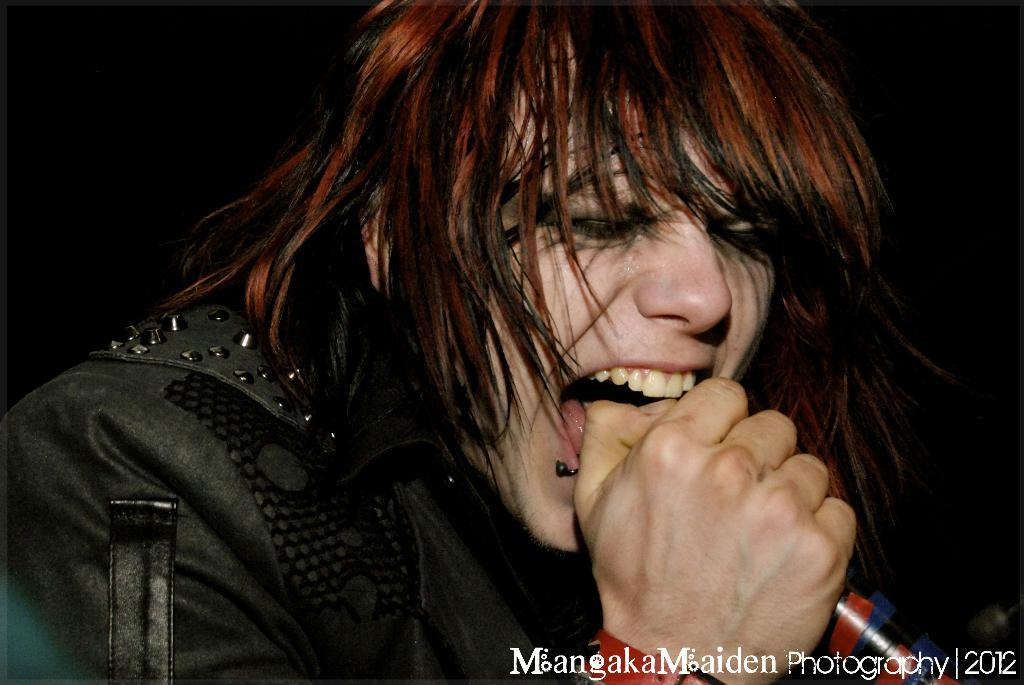What is the main subject of the image? The main subject of the image is a person. What is the person holding in the image? The person is holding a mic. What color is the jacket that the person is wearing? The person is wearing a black color jacket. What time of day is it in the image, and is there a girl present? The time of day cannot be determined from the image, and there is no girl present in the image. What is the limit of the mic that the person is holding? There is no indication of a limit for the mic in the image. 